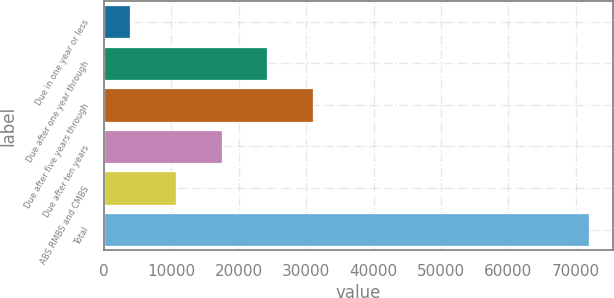Convert chart to OTSL. <chart><loc_0><loc_0><loc_500><loc_500><bar_chart><fcel>Due in one year or less<fcel>Due after one year through<fcel>Due after five years through<fcel>Due after ten years<fcel>ABS RMBS and CMBS<fcel>Total<nl><fcel>3825<fcel>24252<fcel>31061<fcel>17443<fcel>10634<fcel>71915<nl></chart> 